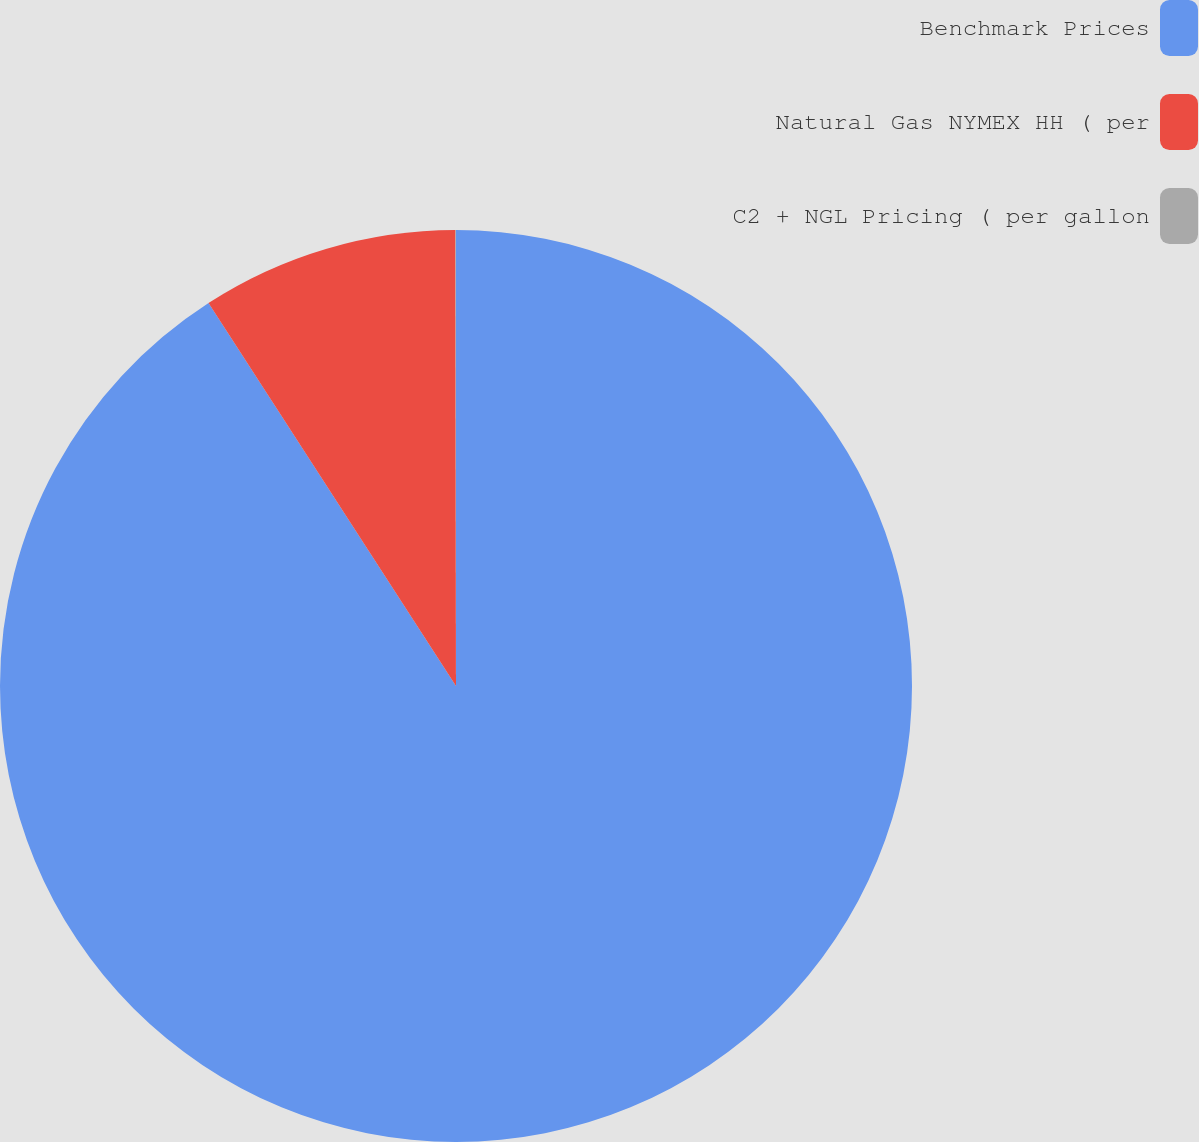Convert chart to OTSL. <chart><loc_0><loc_0><loc_500><loc_500><pie_chart><fcel>Benchmark Prices<fcel>Natural Gas NYMEX HH ( per<fcel>C2 + NGL Pricing ( per gallon<nl><fcel>90.87%<fcel>9.11%<fcel>0.02%<nl></chart> 